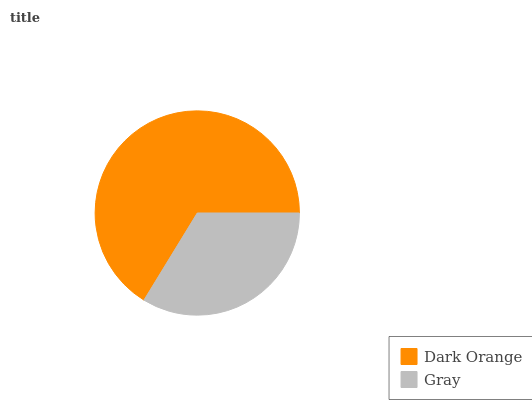Is Gray the minimum?
Answer yes or no. Yes. Is Dark Orange the maximum?
Answer yes or no. Yes. Is Gray the maximum?
Answer yes or no. No. Is Dark Orange greater than Gray?
Answer yes or no. Yes. Is Gray less than Dark Orange?
Answer yes or no. Yes. Is Gray greater than Dark Orange?
Answer yes or no. No. Is Dark Orange less than Gray?
Answer yes or no. No. Is Dark Orange the high median?
Answer yes or no. Yes. Is Gray the low median?
Answer yes or no. Yes. Is Gray the high median?
Answer yes or no. No. Is Dark Orange the low median?
Answer yes or no. No. 